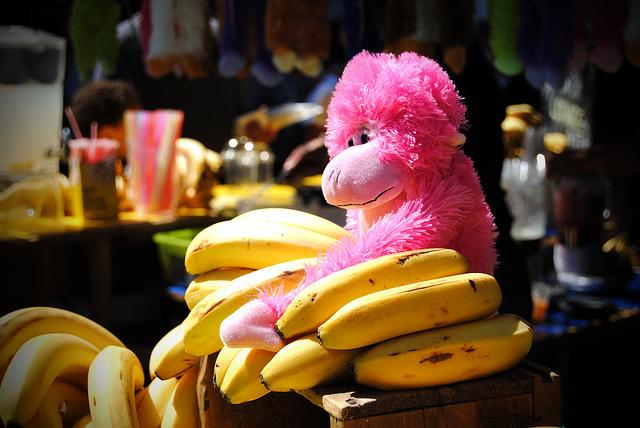What is the pink monkey on the bananas?
Write a very short answer. Stuffed animal. How many banana's in the photo?
Answer briefly. 17. Is this a marketplace?
Write a very short answer. Yes. 